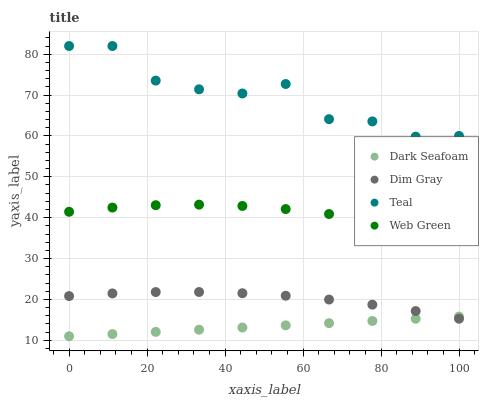Does Dark Seafoam have the minimum area under the curve?
Answer yes or no. Yes. Does Teal have the maximum area under the curve?
Answer yes or no. Yes. Does Dim Gray have the minimum area under the curve?
Answer yes or no. No. Does Dim Gray have the maximum area under the curve?
Answer yes or no. No. Is Dark Seafoam the smoothest?
Answer yes or no. Yes. Is Teal the roughest?
Answer yes or no. Yes. Is Dim Gray the smoothest?
Answer yes or no. No. Is Dim Gray the roughest?
Answer yes or no. No. Does Dark Seafoam have the lowest value?
Answer yes or no. Yes. Does Dim Gray have the lowest value?
Answer yes or no. No. Does Teal have the highest value?
Answer yes or no. Yes. Does Dim Gray have the highest value?
Answer yes or no. No. Is Dark Seafoam less than Teal?
Answer yes or no. Yes. Is Teal greater than Dark Seafoam?
Answer yes or no. Yes. Does Dark Seafoam intersect Dim Gray?
Answer yes or no. Yes. Is Dark Seafoam less than Dim Gray?
Answer yes or no. No. Is Dark Seafoam greater than Dim Gray?
Answer yes or no. No. Does Dark Seafoam intersect Teal?
Answer yes or no. No. 